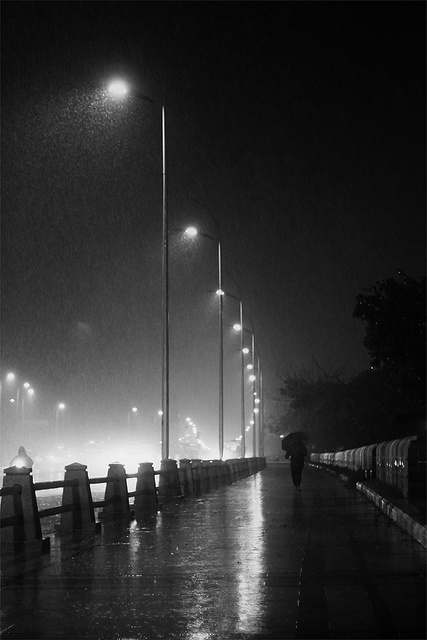Describe the objects in this image and their specific colors. I can see people in black tones, umbrella in black tones, and people in darkgray, lightgray, gray, and black tones in this image. 